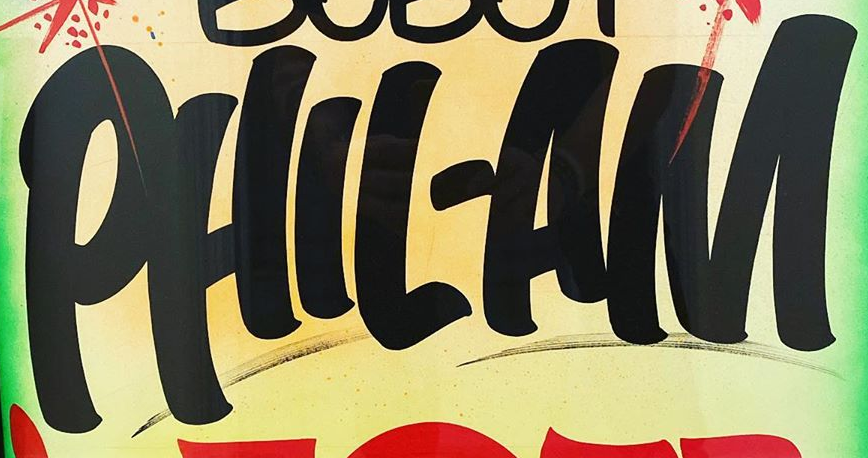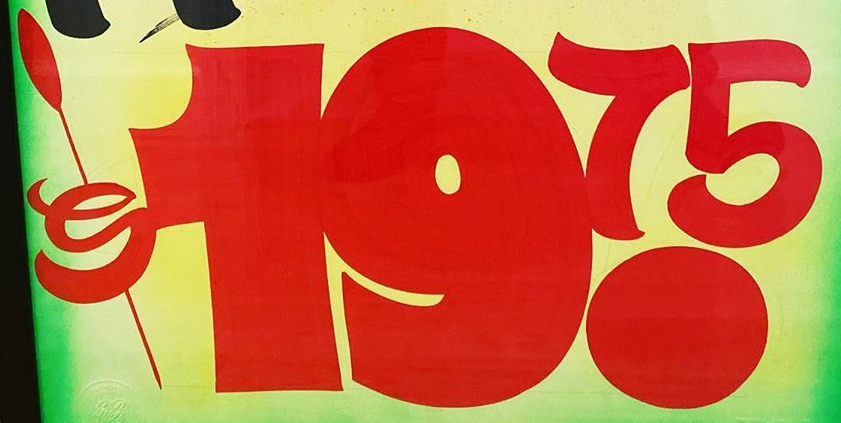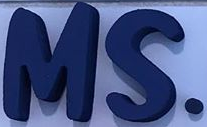Read the text content from these images in order, separated by a semicolon. PHIL-AM; $19.75; MS. 